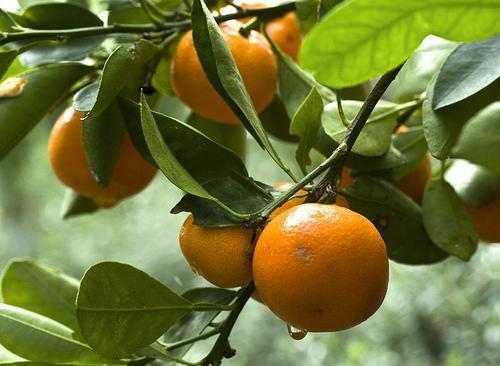How many oranges are there?
Give a very brief answer. 8. 